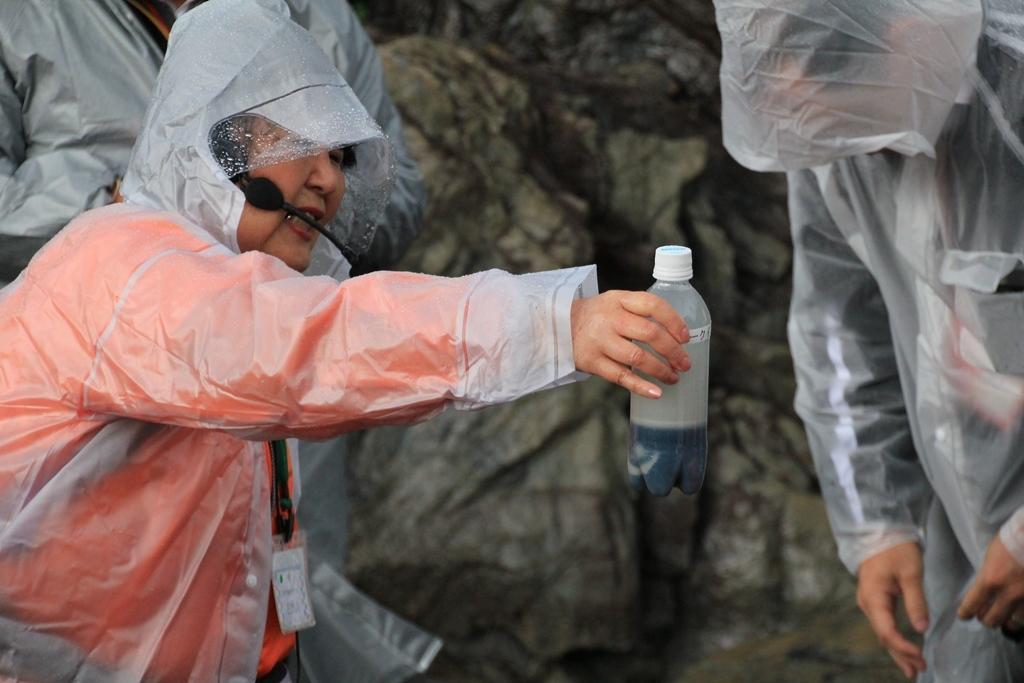How would you summarize this image in a sentence or two? In this picture there are three people standing wearing a rain coat, and the person in red dress holding a bottle. Background of this people is a rock. 